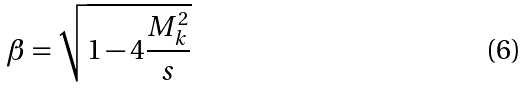<formula> <loc_0><loc_0><loc_500><loc_500>\beta = \sqrt { 1 - 4 \frac { M _ { k } ^ { 2 } } { s } }</formula> 